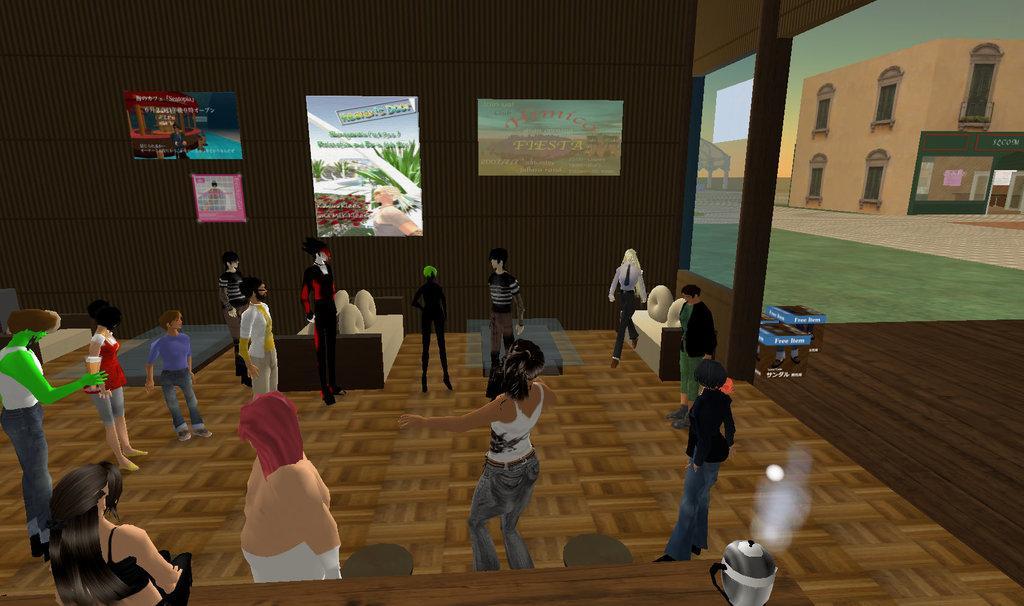Can you describe this image briefly? In this picture I can see the animated image of the persons who are standing round. Beside them I can see the table and couches. On the right I can see the building and sky. In the back I can see the posts which are placed on the wall. 